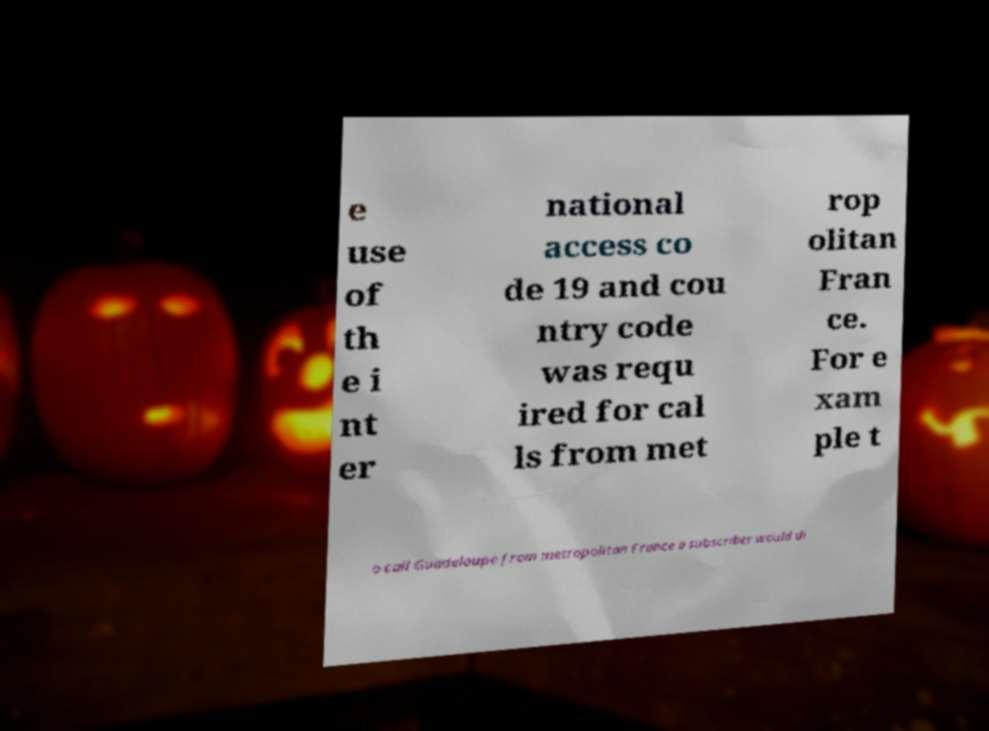Could you assist in decoding the text presented in this image and type it out clearly? e use of th e i nt er national access co de 19 and cou ntry code was requ ired for cal ls from met rop olitan Fran ce. For e xam ple t o call Guadeloupe from metropolitan France a subscriber would di 